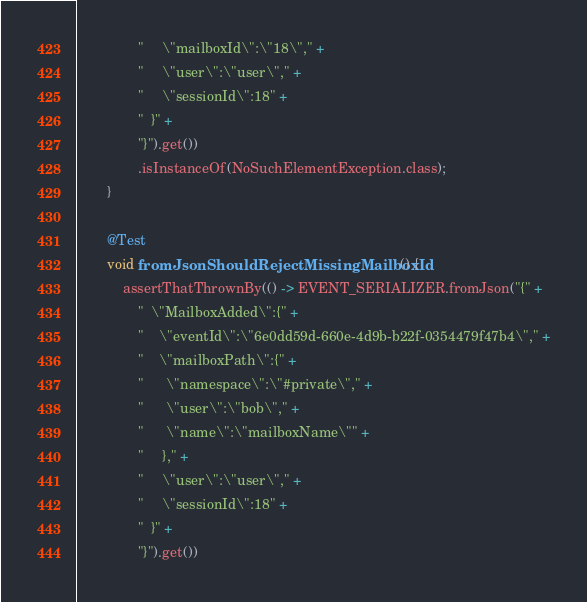<code> <loc_0><loc_0><loc_500><loc_500><_Java_>                "     \"mailboxId\":\"18\"," +
                "     \"user\":\"user\"," +
                "     \"sessionId\":18" +
                "  }" +
                "}").get())
                .isInstanceOf(NoSuchElementException.class);
        }

        @Test
        void fromJsonShouldRejectMissingMailboxId() {
            assertThatThrownBy(() -> EVENT_SERIALIZER.fromJson("{" +
                "  \"MailboxAdded\":{" +
                "    \"eventId\":\"6e0dd59d-660e-4d9b-b22f-0354479f47b4\"," +
                "    \"mailboxPath\":{" +
                "      \"namespace\":\"#private\"," +
                "      \"user\":\"bob\"," +
                "      \"name\":\"mailboxName\"" +
                "     }," +
                "     \"user\":\"user\"," +
                "     \"sessionId\":18" +
                "  }" +
                "}").get())</code> 